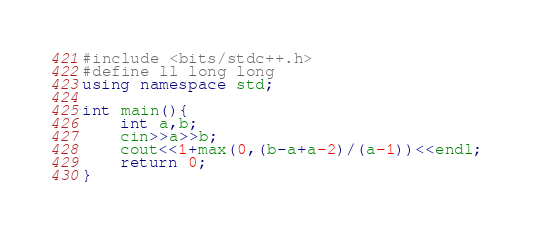Convert code to text. <code><loc_0><loc_0><loc_500><loc_500><_C++_>#include <bits/stdc++.h>
#define ll long long
using namespace std;

int main(){
    int a,b;
    cin>>a>>b;
    cout<<1+max(0,(b-a+a-2)/(a-1))<<endl;
    return 0;
}
</code> 